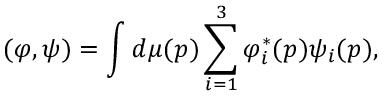<formula> <loc_0><loc_0><loc_500><loc_500>( \varphi , \psi ) = \int d \mu ( p ) \sum _ { i = 1 } ^ { 3 } \varphi _ { i } ^ { \ast } ( p ) \psi _ { i } ( p ) ,</formula> 